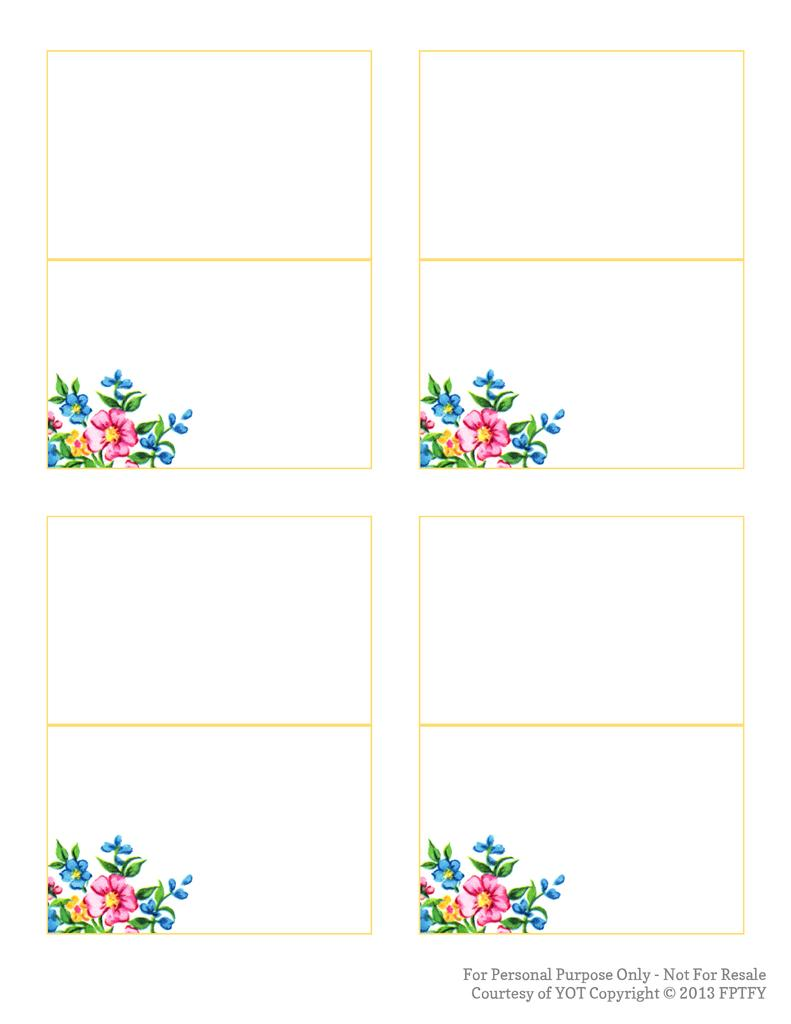What is the main theme of the image? The main theme of the image is a collage of floral design. Can you describe the elements that make up the collage? The collage consists of various floral designs and patterns. How many stockings are hanging on the wall in the image? There are no stockings or walls present in the image; it is a collage of floral designs. What type of yak can be seen grazing in the background of the image? There are no yaks or backgrounds present in the image; it is a collage of floral designs. 